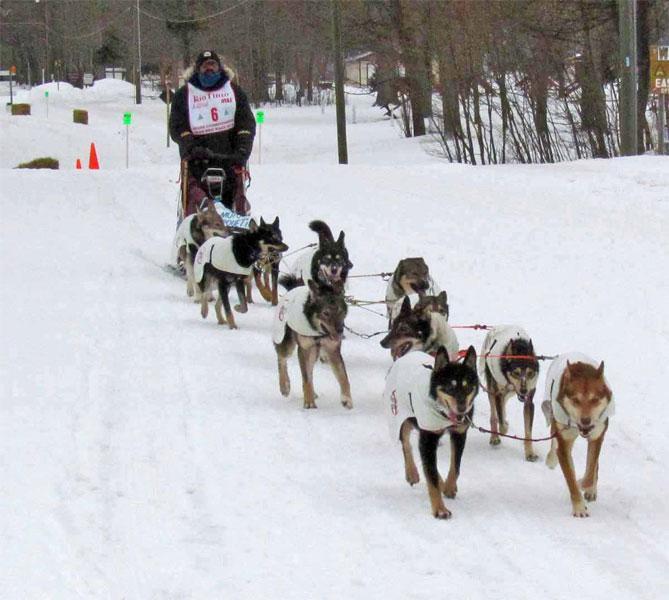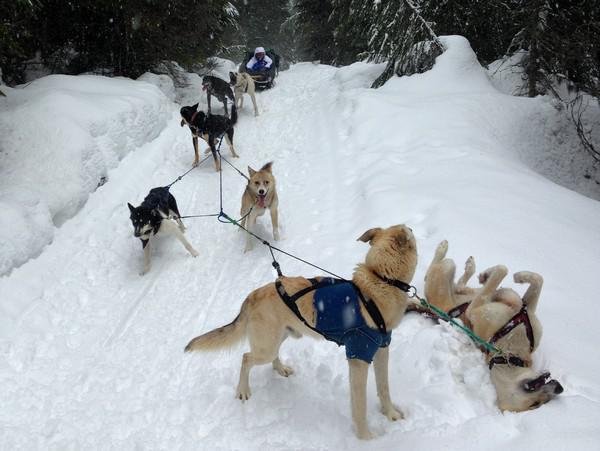The first image is the image on the left, the second image is the image on the right. Analyze the images presented: Is the assertion "There are people in both images." valid? Answer yes or no. Yes. 